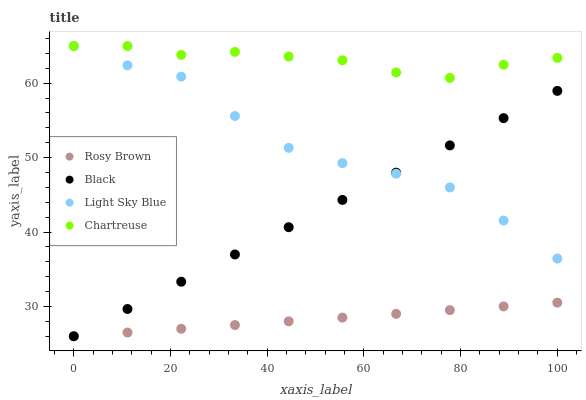Does Rosy Brown have the minimum area under the curve?
Answer yes or no. Yes. Does Chartreuse have the maximum area under the curve?
Answer yes or no. Yes. Does Black have the minimum area under the curve?
Answer yes or no. No. Does Black have the maximum area under the curve?
Answer yes or no. No. Is Rosy Brown the smoothest?
Answer yes or no. Yes. Is Light Sky Blue the roughest?
Answer yes or no. Yes. Is Black the smoothest?
Answer yes or no. No. Is Black the roughest?
Answer yes or no. No. Does Rosy Brown have the lowest value?
Answer yes or no. Yes. Does Light Sky Blue have the lowest value?
Answer yes or no. No. Does Light Sky Blue have the highest value?
Answer yes or no. Yes. Does Black have the highest value?
Answer yes or no. No. Is Rosy Brown less than Chartreuse?
Answer yes or no. Yes. Is Chartreuse greater than Rosy Brown?
Answer yes or no. Yes. Does Chartreuse intersect Light Sky Blue?
Answer yes or no. Yes. Is Chartreuse less than Light Sky Blue?
Answer yes or no. No. Is Chartreuse greater than Light Sky Blue?
Answer yes or no. No. Does Rosy Brown intersect Chartreuse?
Answer yes or no. No. 